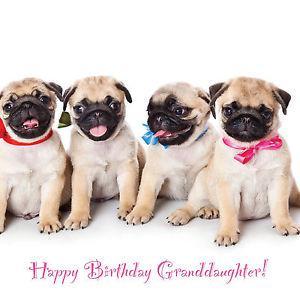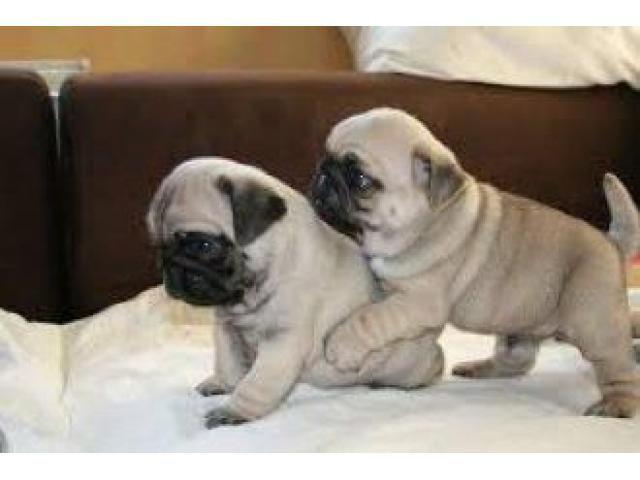The first image is the image on the left, the second image is the image on the right. For the images shown, is this caption "The left image contains exactly one pug dog." true? Answer yes or no. No. The first image is the image on the left, the second image is the image on the right. Evaluate the accuracy of this statement regarding the images: "There is exactly one dog in every image and at least one dog is looking directly at the camera.". Is it true? Answer yes or no. No. 